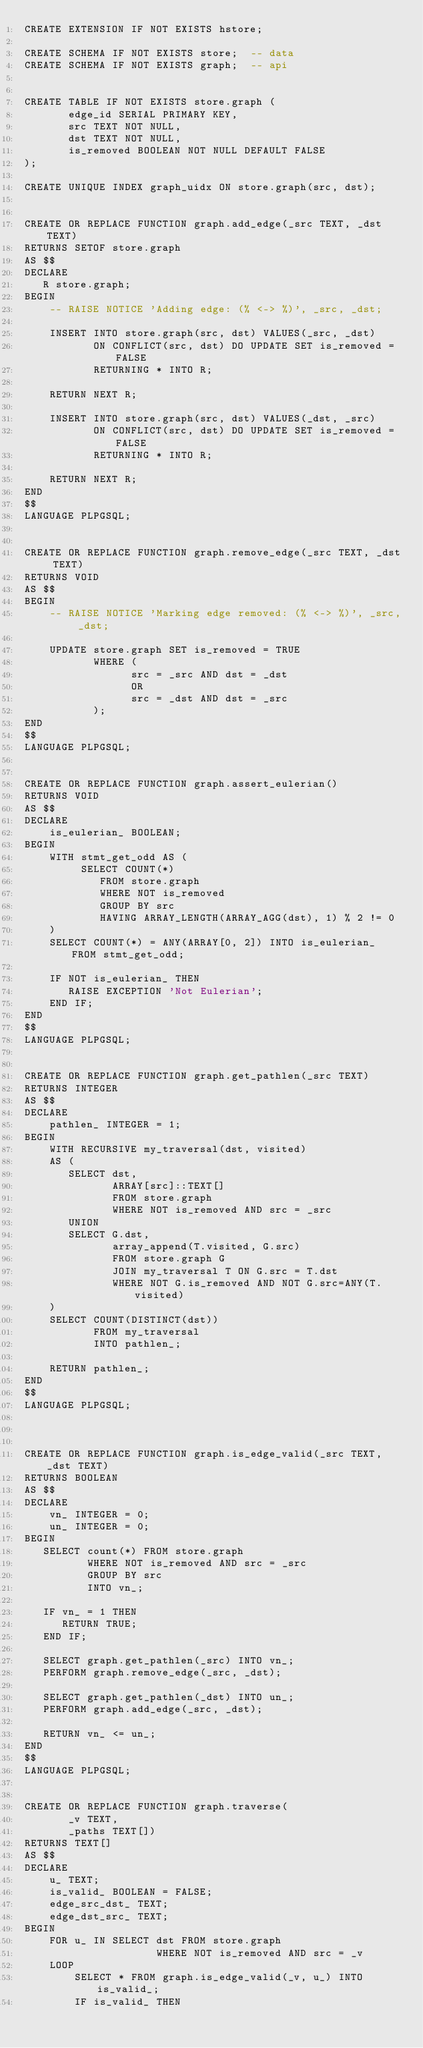<code> <loc_0><loc_0><loc_500><loc_500><_SQL_>CREATE EXTENSION IF NOT EXISTS hstore;

CREATE SCHEMA IF NOT EXISTS store;  -- data
CREATE SCHEMA IF NOT EXISTS graph;  -- api


CREATE TABLE IF NOT EXISTS store.graph (
       edge_id SERIAL PRIMARY KEY,
       src TEXT NOT NULL,
       dst TEXT NOT NULL,
       is_removed BOOLEAN NOT NULL DEFAULT FALSE
);

CREATE UNIQUE INDEX graph_uidx ON store.graph(src, dst);


CREATE OR REPLACE FUNCTION graph.add_edge(_src TEXT, _dst TEXT)
RETURNS SETOF store.graph
AS $$
DECLARE
   R store.graph;
BEGIN
    -- RAISE NOTICE 'Adding edge: (% <-> %)', _src, _dst;

    INSERT INTO store.graph(src, dst) VALUES(_src, _dst)
           ON CONFLICT(src, dst) DO UPDATE SET is_removed = FALSE
           RETURNING * INTO R;

    RETURN NEXT R;

    INSERT INTO store.graph(src, dst) VALUES(_dst, _src)
           ON CONFLICT(src, dst) DO UPDATE SET is_removed = FALSE
           RETURNING * INTO R;

    RETURN NEXT R;
END
$$
LANGUAGE PLPGSQL;


CREATE OR REPLACE FUNCTION graph.remove_edge(_src TEXT, _dst TEXT)
RETURNS VOID
AS $$
BEGIN
    -- RAISE NOTICE 'Marking edge removed: (% <-> %)', _src, _dst;

    UPDATE store.graph SET is_removed = TRUE
           WHERE (
                 src = _src AND dst = _dst
                 OR
                 src = _dst AND dst = _src
           );
END
$$
LANGUAGE PLPGSQL;


CREATE OR REPLACE FUNCTION graph.assert_eulerian()
RETURNS VOID
AS $$
DECLARE
    is_eulerian_ BOOLEAN;
BEGIN
    WITH stmt_get_odd AS (
         SELECT COUNT(*)
            FROM store.graph
            WHERE NOT is_removed
            GROUP BY src
            HAVING ARRAY_LENGTH(ARRAY_AGG(dst), 1) % 2 != 0
    )
    SELECT COUNT(*) = ANY(ARRAY[0, 2]) INTO is_eulerian_ FROM stmt_get_odd;

    IF NOT is_eulerian_ THEN
       RAISE EXCEPTION 'Not Eulerian';
    END IF;
END
$$
LANGUAGE PLPGSQL;


CREATE OR REPLACE FUNCTION graph.get_pathlen(_src TEXT)
RETURNS INTEGER
AS $$
DECLARE
    pathlen_ INTEGER = 1;
BEGIN
    WITH RECURSIVE my_traversal(dst, visited)
    AS (
       SELECT dst,
              ARRAY[src]::TEXT[]
              FROM store.graph
              WHERE NOT is_removed AND src = _src
       UNION
       SELECT G.dst,
              array_append(T.visited, G.src)
              FROM store.graph G
              JOIN my_traversal T ON G.src = T.dst
              WHERE NOT G.is_removed AND NOT G.src=ANY(T.visited)
    )
    SELECT COUNT(DISTINCT(dst))
           FROM my_traversal
           INTO pathlen_;

    RETURN pathlen_;
END
$$
LANGUAGE PLPGSQL;



CREATE OR REPLACE FUNCTION graph.is_edge_valid(_src TEXT, _dst TEXT)
RETURNS BOOLEAN
AS $$
DECLARE
    vn_ INTEGER = 0;
    un_ INTEGER = 0;
BEGIN
   SELECT count(*) FROM store.graph
          WHERE NOT is_removed AND src = _src
          GROUP BY src
          INTO vn_;

   IF vn_ = 1 THEN
      RETURN TRUE;
   END IF;

   SELECT graph.get_pathlen(_src) INTO vn_;
   PERFORM graph.remove_edge(_src, _dst);

   SELECT graph.get_pathlen(_dst) INTO un_;
   PERFORM graph.add_edge(_src, _dst);

   RETURN vn_ <= un_;
END
$$
LANGUAGE PLPGSQL;


CREATE OR REPLACE FUNCTION graph.traverse(
       _v TEXT,
       _paths TEXT[])
RETURNS TEXT[]
AS $$
DECLARE
    u_ TEXT;
    is_valid_ BOOLEAN = FALSE;
    edge_src_dst_ TEXT;
    edge_dst_src_ TEXT;
BEGIN
    FOR u_ IN SELECT dst FROM store.graph
                     WHERE NOT is_removed AND src = _v
    LOOP
        SELECT * FROM graph.is_edge_valid(_v, u_) INTO is_valid_;
        IF is_valid_ THEN</code> 